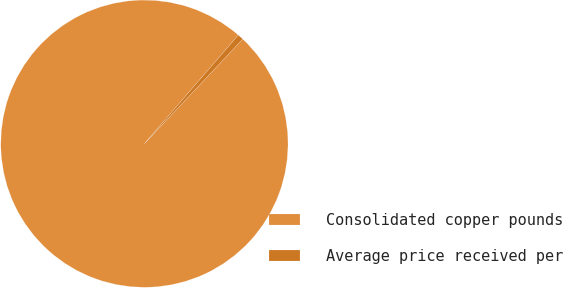Convert chart. <chart><loc_0><loc_0><loc_500><loc_500><pie_chart><fcel>Consolidated copper pounds<fcel>Average price received per<nl><fcel>99.34%<fcel>0.66%<nl></chart> 